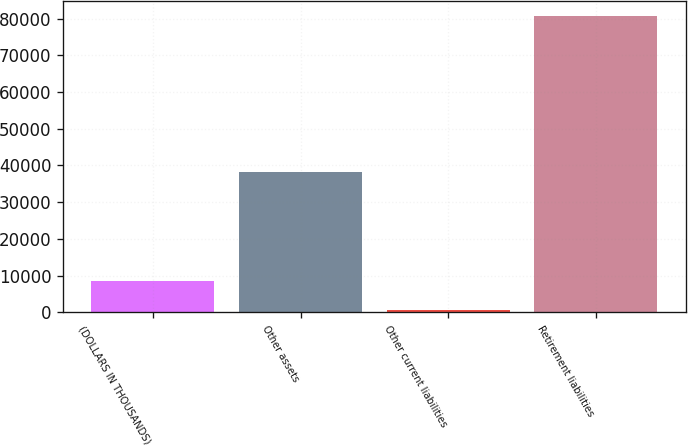Convert chart to OTSL. <chart><loc_0><loc_0><loc_500><loc_500><bar_chart><fcel>(DOLLARS IN THOUSANDS)<fcel>Other assets<fcel>Other current liabilities<fcel>Retirement liabilities<nl><fcel>8656.2<fcel>38095<fcel>652<fcel>80694<nl></chart> 